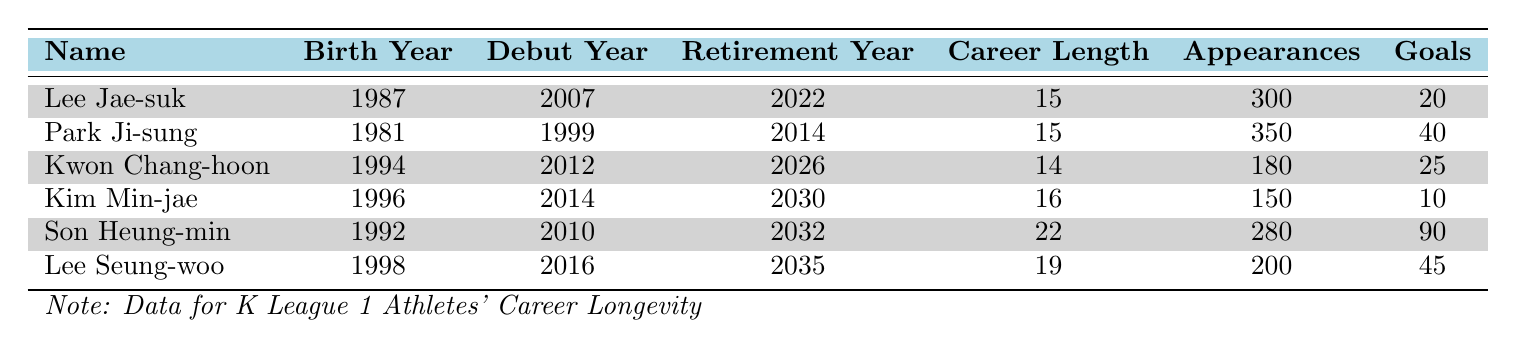What is the career length of Lee Jae-suk? The table shows that Lee Jae-suk has a career length of 15 years, as indicated in the "Career Length" column for his row.
Answer: 15 Which player has the most appearances? Looking at the "Appearances" column, Park Ji-sung has the highest number of appearances with a total of 350.
Answer: 350 Is Kwon Chang-hoon a midfielder? Kwon Chang-hoon is listed as a Forward in the "Position" column, so the statement is false.
Answer: No What is the average number of goals scored by the players listed? To find the average, sum the goals: (20 + 40 + 25 + 10 + 90 + 45) = 230. Then divide by the number of players, which is 6. So, the average is 230/6 = 38.33.
Answer: 38.33 Which player's career length is shorter than 20 years? Comparing the "Career Length" values, both Kwon Chang-hoon (14 years) and Lee Jae-suk (15 years) have career lengths shorter than 20 years.
Answer: Kwon Chang-hoon, Lee Jae-suk What is the total number of goals scored by defenders? The defenders in the table are Lee Jae-suk and Kim Min-jae. Their goals are 20 and 10, respectively. Adding those gives a total of 30 goals scored by defenders.
Answer: 30 Which player had their debut year in 2010? By checking the "Debut Year" column, Son Heung-min is the player who made his debut in 2010.
Answer: Son Heung-min Is it true that Lee Seung-woo has more goals than Kim Min-jae? Lee Seung-woo scored 45 goals while Kim Min-jae scored 10 goals. Since 45 is greater than 10, the statement is true.
Answer: Yes What is the difference in career length between the longest and shortest careers in the table? The longest career is Son Heung-min's at 22 years, while the shortest is Kwon Chang-hoon's at 14 years. The difference is 22 - 14 = 8 years.
Answer: 8 